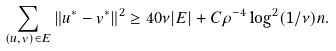<formula> <loc_0><loc_0><loc_500><loc_500>\sum _ { ( u , v ) \in E } \| u ^ { * } - v ^ { * } \| ^ { 2 } \geq 4 0 \nu | E | + C \rho ^ { - 4 } \log ^ { 2 } ( 1 / \nu ) n .</formula> 